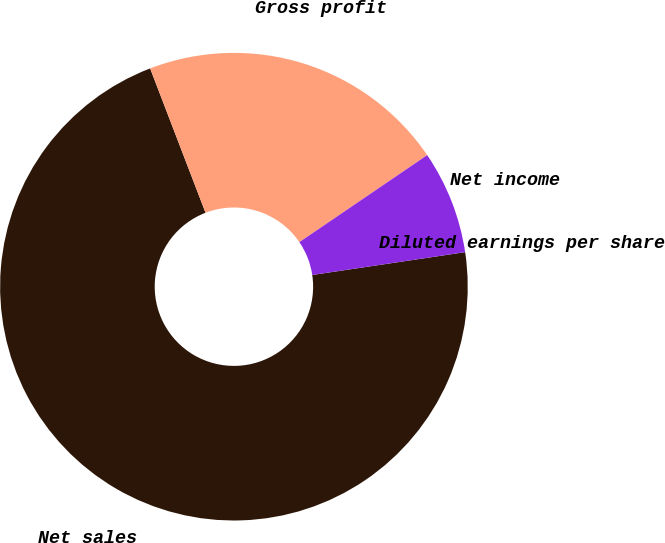<chart> <loc_0><loc_0><loc_500><loc_500><pie_chart><fcel>Net sales<fcel>Gross profit<fcel>Net income<fcel>Diluted earnings per share<nl><fcel>71.52%<fcel>21.32%<fcel>7.15%<fcel>0.0%<nl></chart> 